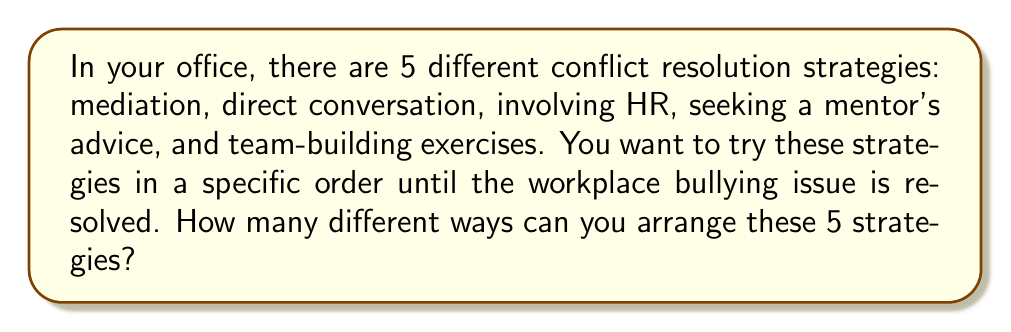Can you answer this question? This problem can be solved using the concept of permutations. A permutation is an arrangement of objects where order matters.

In this case:
1. We have 5 distinct conflict resolution strategies.
2. We want to arrange all 5 of these strategies.
3. The order in which we try these strategies matters.

The formula for permutations of n distinct objects is:

$$P(n) = n!$$

Where $n!$ represents the factorial of n.

For our problem:
$$P(5) = 5!$$

To calculate 5!, we multiply all integers from 1 to 5:

$$5! = 5 \times 4 \times 3 \times 2 \times 1 = 120$$

Therefore, there are 120 different ways to arrange these 5 conflict resolution strategies.
Answer: 120 ways 